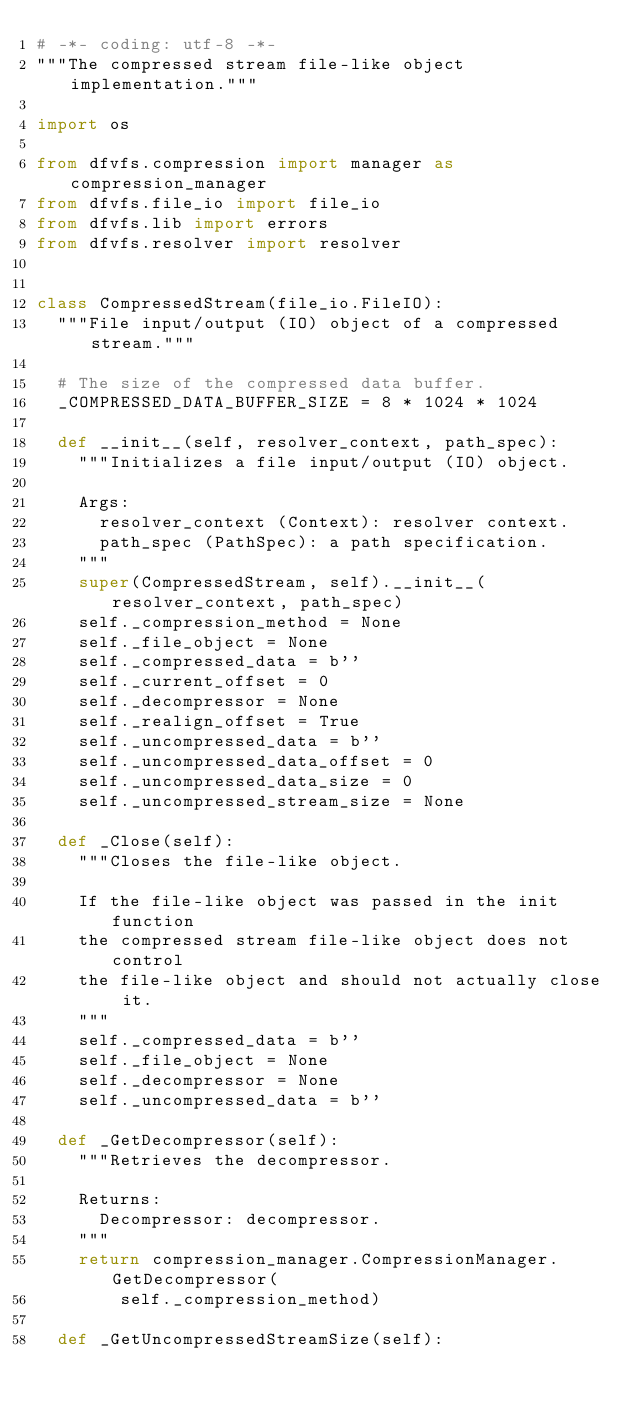<code> <loc_0><loc_0><loc_500><loc_500><_Python_># -*- coding: utf-8 -*-
"""The compressed stream file-like object implementation."""

import os

from dfvfs.compression import manager as compression_manager
from dfvfs.file_io import file_io
from dfvfs.lib import errors
from dfvfs.resolver import resolver


class CompressedStream(file_io.FileIO):
  """File input/output (IO) object of a compressed stream."""

  # The size of the compressed data buffer.
  _COMPRESSED_DATA_BUFFER_SIZE = 8 * 1024 * 1024

  def __init__(self, resolver_context, path_spec):
    """Initializes a file input/output (IO) object.

    Args:
      resolver_context (Context): resolver context.
      path_spec (PathSpec): a path specification.
    """
    super(CompressedStream, self).__init__(resolver_context, path_spec)
    self._compression_method = None
    self._file_object = None
    self._compressed_data = b''
    self._current_offset = 0
    self._decompressor = None
    self._realign_offset = True
    self._uncompressed_data = b''
    self._uncompressed_data_offset = 0
    self._uncompressed_data_size = 0
    self._uncompressed_stream_size = None

  def _Close(self):
    """Closes the file-like object.

    If the file-like object was passed in the init function
    the compressed stream file-like object does not control
    the file-like object and should not actually close it.
    """
    self._compressed_data = b''
    self._file_object = None
    self._decompressor = None
    self._uncompressed_data = b''

  def _GetDecompressor(self):
    """Retrieves the decompressor.

    Returns:
      Decompressor: decompressor.
    """
    return compression_manager.CompressionManager.GetDecompressor(
        self._compression_method)

  def _GetUncompressedStreamSize(self):</code> 